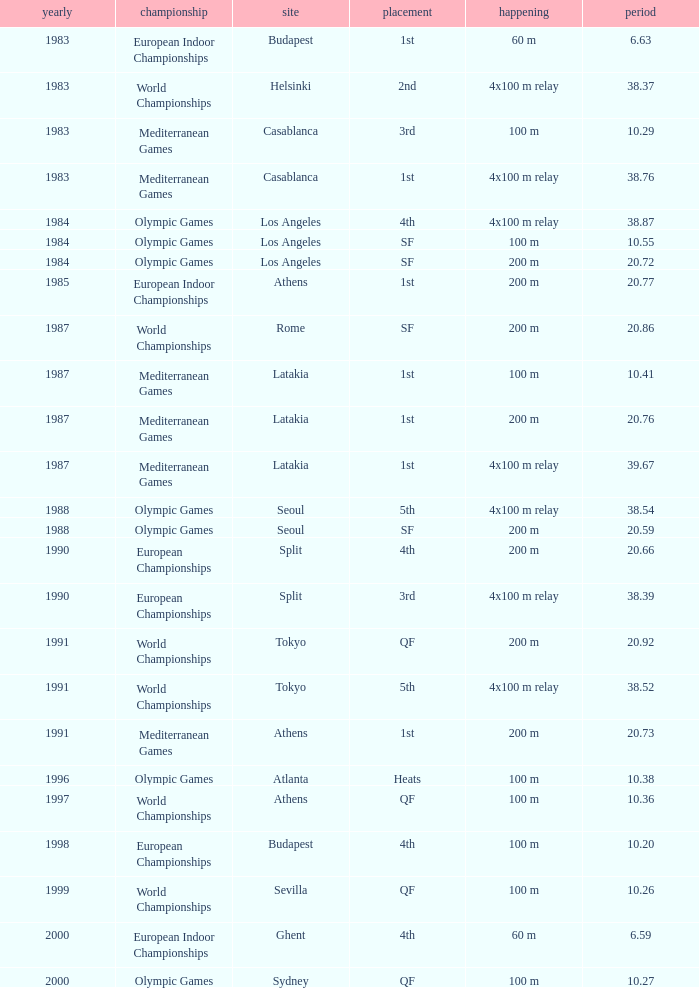What Event has a Position of 1st, a Year of 1983, and a Venue of budapest? 60 m. 